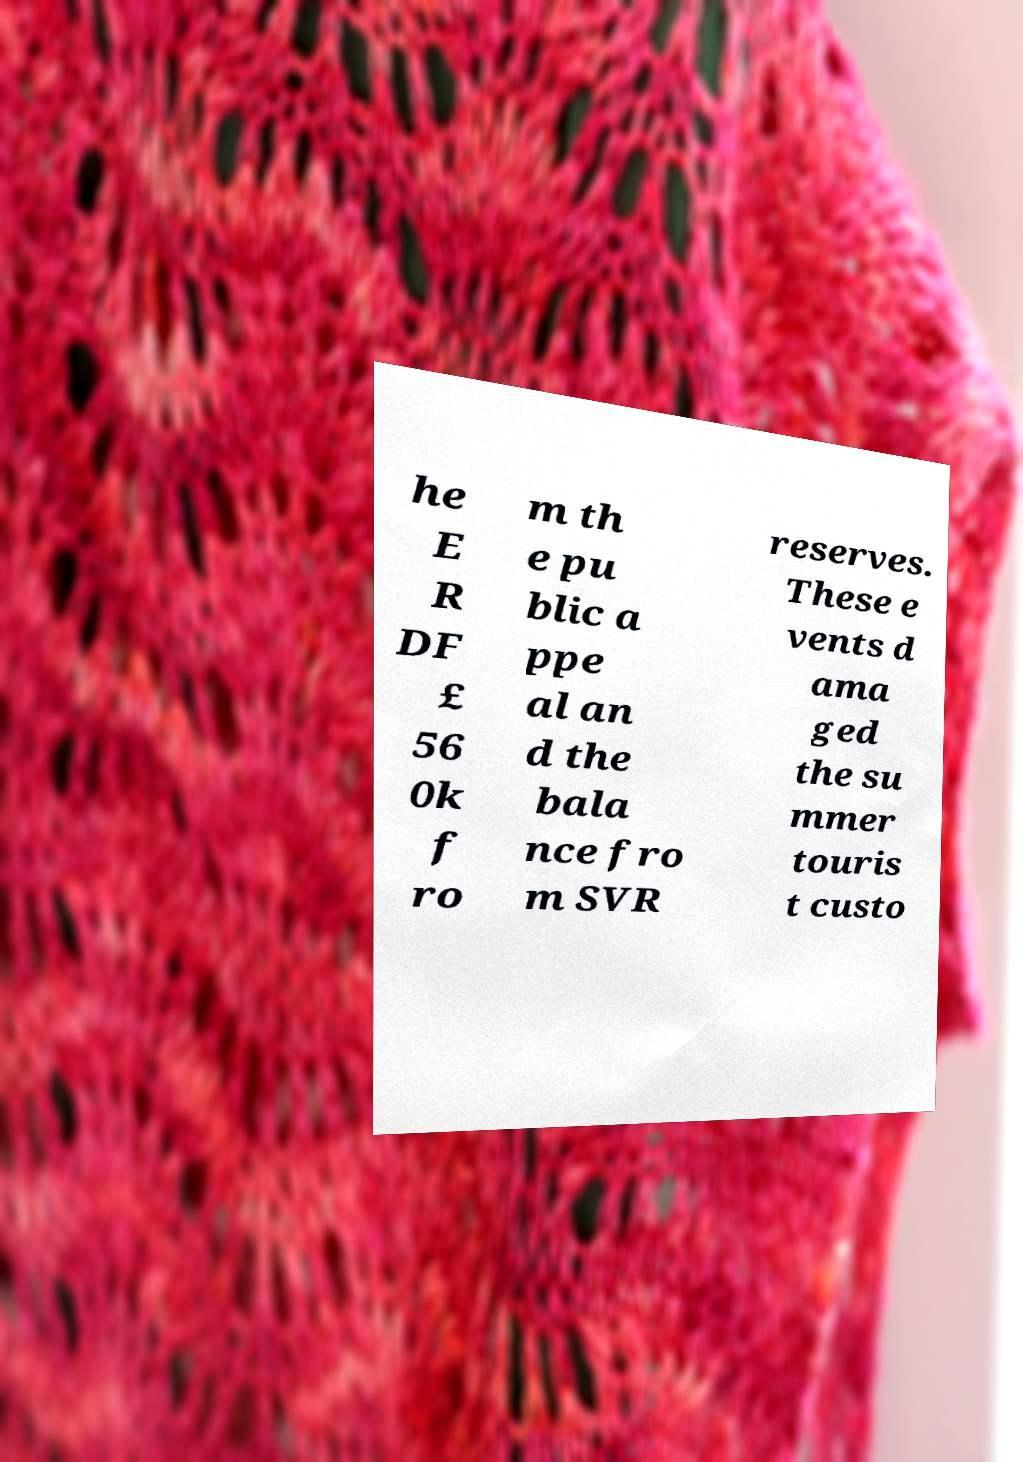Please read and relay the text visible in this image. What does it say? he E R DF £ 56 0k f ro m th e pu blic a ppe al an d the bala nce fro m SVR reserves. These e vents d ama ged the su mmer touris t custo 